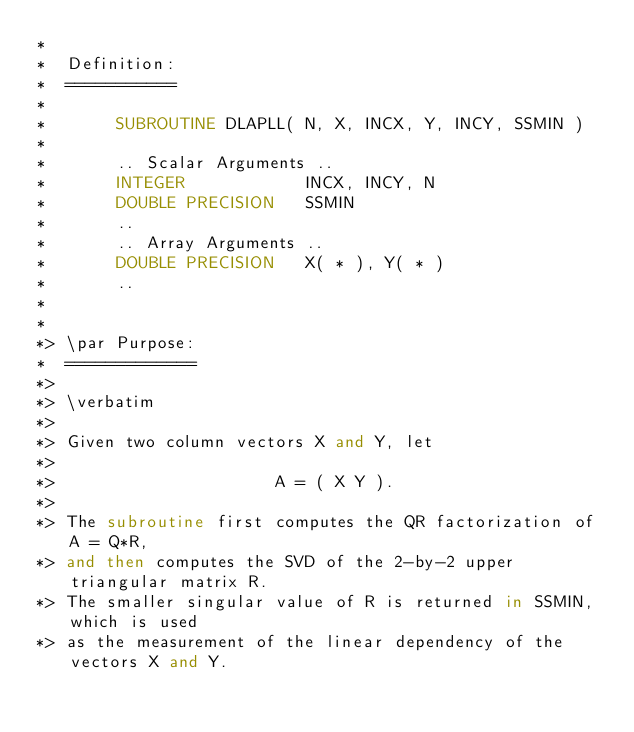<code> <loc_0><loc_0><loc_500><loc_500><_FORTRAN_>*
*  Definition:
*  ===========
*
*       SUBROUTINE DLAPLL( N, X, INCX, Y, INCY, SSMIN )
*
*       .. Scalar Arguments ..
*       INTEGER            INCX, INCY, N
*       DOUBLE PRECISION   SSMIN
*       ..
*       .. Array Arguments ..
*       DOUBLE PRECISION   X( * ), Y( * )
*       ..
*
*
*> \par Purpose:
*  =============
*>
*> \verbatim
*>
*> Given two column vectors X and Y, let
*>
*>                      A = ( X Y ).
*>
*> The subroutine first computes the QR factorization of A = Q*R,
*> and then computes the SVD of the 2-by-2 upper triangular matrix R.
*> The smaller singular value of R is returned in SSMIN, which is used
*> as the measurement of the linear dependency of the vectors X and Y.</code> 